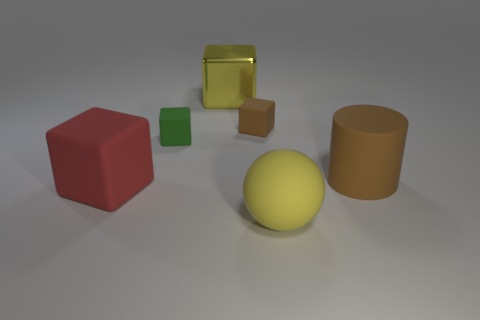Subtract 1 cubes. How many cubes are left? 3 Add 3 shiny cubes. How many objects exist? 9 Subtract all balls. How many objects are left? 5 Subtract 1 yellow cubes. How many objects are left? 5 Subtract all big gray cylinders. Subtract all cylinders. How many objects are left? 5 Add 6 large brown objects. How many large brown objects are left? 7 Add 4 small brown cylinders. How many small brown cylinders exist? 4 